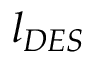Convert formula to latex. <formula><loc_0><loc_0><loc_500><loc_500>l _ { D E S }</formula> 